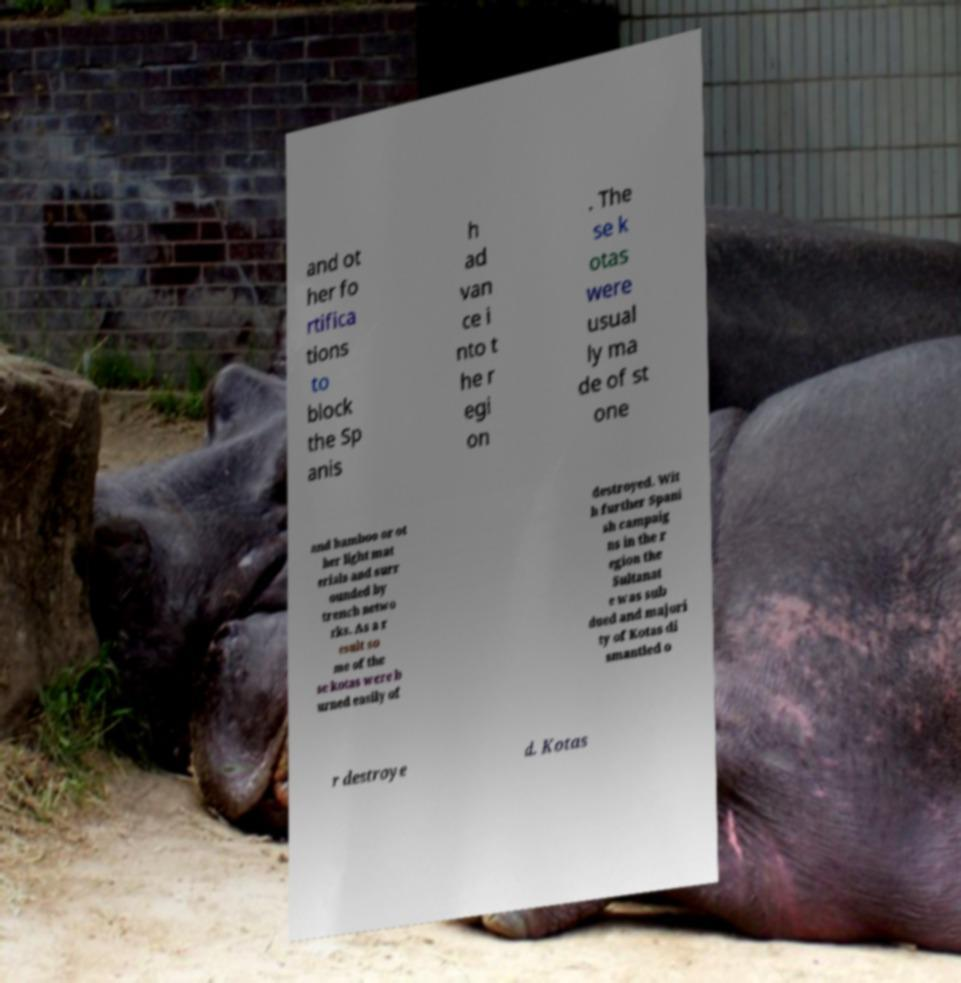I need the written content from this picture converted into text. Can you do that? and ot her fo rtifica tions to block the Sp anis h ad van ce i nto t he r egi on . The se k otas were usual ly ma de of st one and bamboo or ot her light mat erials and surr ounded by trench netwo rks. As a r esult so me of the se kotas were b urned easily of destroyed. Wit h further Spani sh campaig ns in the r egion the Sultanat e was sub dued and majori ty of Kotas di smantled o r destroye d. Kotas 